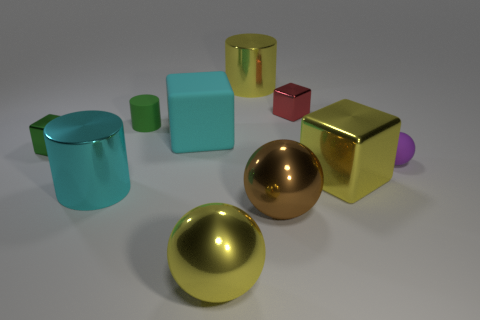Subtract all big yellow blocks. How many blocks are left? 3 Subtract all blue cubes. Subtract all red balls. How many cubes are left? 4 Subtract all cylinders. How many objects are left? 7 Subtract all tiny things. Subtract all small purple matte balls. How many objects are left? 5 Add 6 yellow cylinders. How many yellow cylinders are left? 7 Add 3 large rubber things. How many large rubber things exist? 4 Subtract 1 cyan cylinders. How many objects are left? 9 